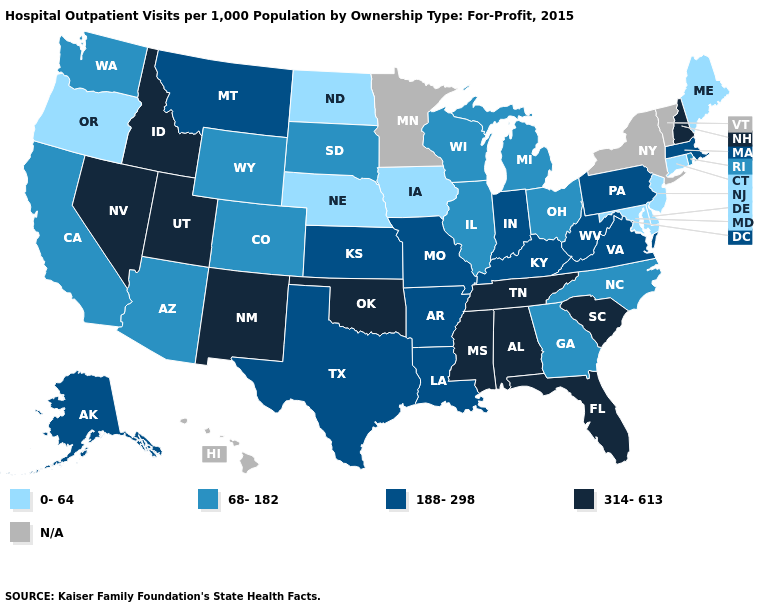Name the states that have a value in the range 188-298?
Give a very brief answer. Alaska, Arkansas, Indiana, Kansas, Kentucky, Louisiana, Massachusetts, Missouri, Montana, Pennsylvania, Texas, Virginia, West Virginia. Among the states that border Wyoming , does South Dakota have the lowest value?
Quick response, please. No. What is the value of Montana?
Give a very brief answer. 188-298. Does the first symbol in the legend represent the smallest category?
Concise answer only. Yes. Among the states that border Vermont , does New Hampshire have the lowest value?
Short answer required. No. What is the value of Oklahoma?
Be succinct. 314-613. What is the value of California?
Give a very brief answer. 68-182. Does Missouri have the highest value in the USA?
Quick response, please. No. Name the states that have a value in the range 0-64?
Be succinct. Connecticut, Delaware, Iowa, Maine, Maryland, Nebraska, New Jersey, North Dakota, Oregon. What is the lowest value in states that border Connecticut?
Write a very short answer. 68-182. Is the legend a continuous bar?
Quick response, please. No. What is the value of New Jersey?
Write a very short answer. 0-64. Name the states that have a value in the range N/A?
Answer briefly. Hawaii, Minnesota, New York, Vermont. 